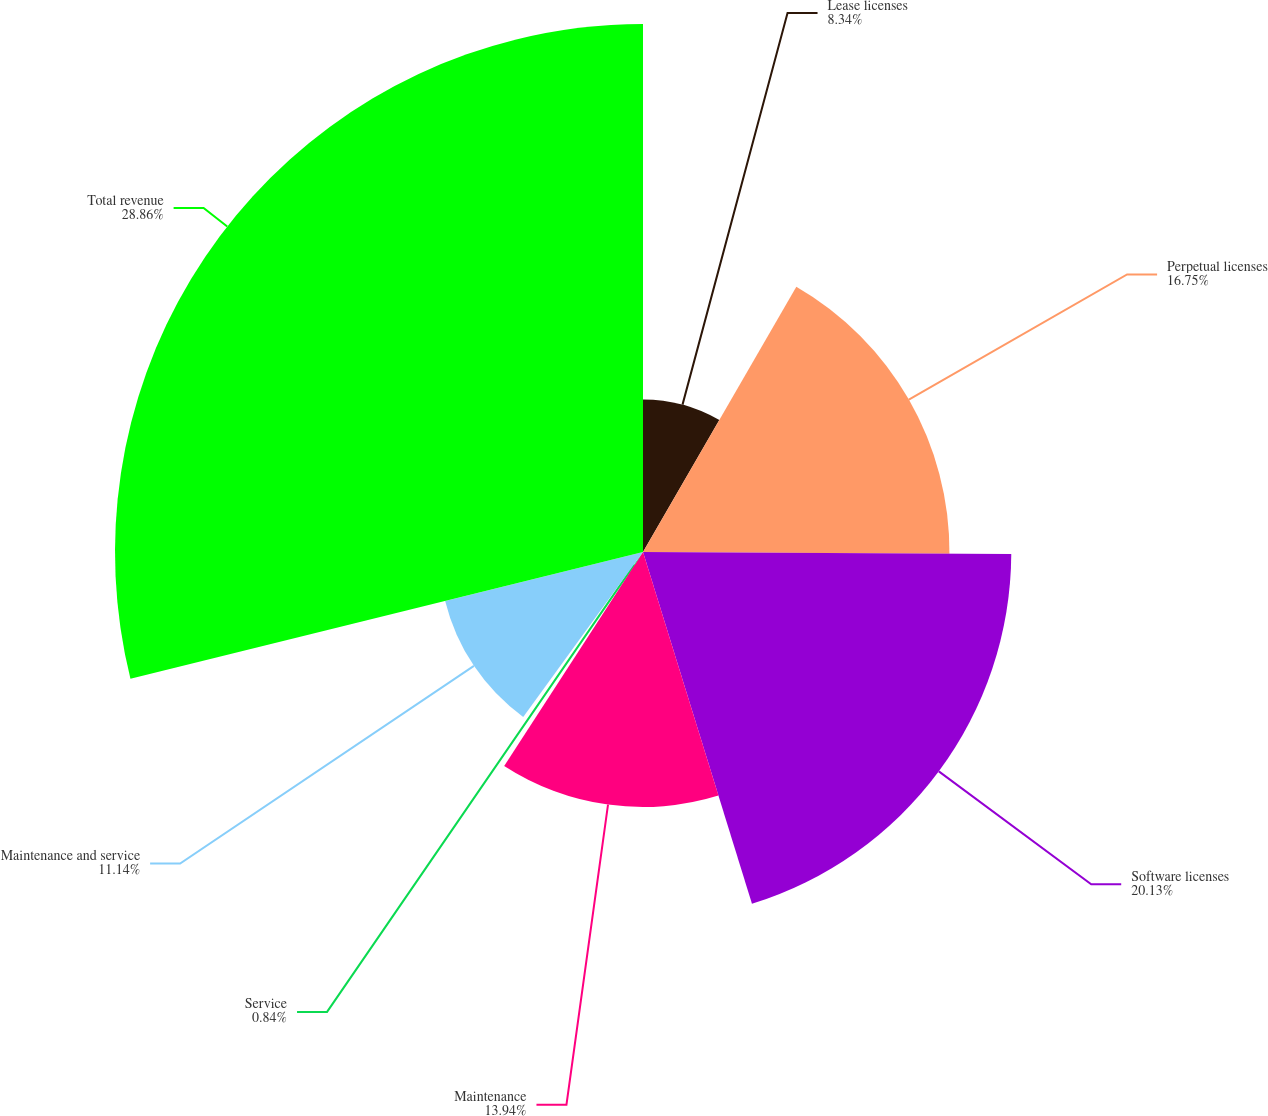Convert chart. <chart><loc_0><loc_0><loc_500><loc_500><pie_chart><fcel>Lease licenses<fcel>Perpetual licenses<fcel>Software licenses<fcel>Maintenance<fcel>Service<fcel>Maintenance and service<fcel>Total revenue<nl><fcel>8.34%<fcel>16.75%<fcel>20.13%<fcel>13.94%<fcel>0.84%<fcel>11.14%<fcel>28.86%<nl></chart> 